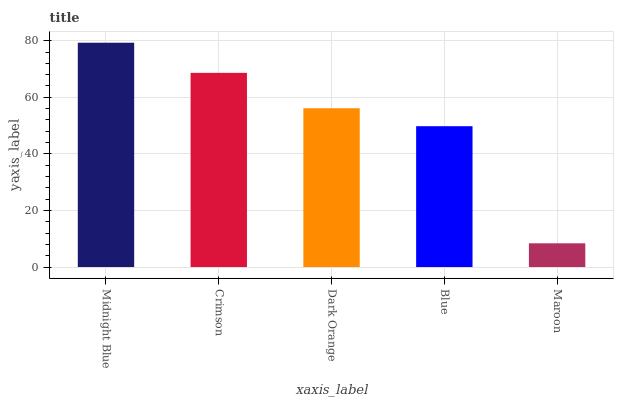Is Maroon the minimum?
Answer yes or no. Yes. Is Midnight Blue the maximum?
Answer yes or no. Yes. Is Crimson the minimum?
Answer yes or no. No. Is Crimson the maximum?
Answer yes or no. No. Is Midnight Blue greater than Crimson?
Answer yes or no. Yes. Is Crimson less than Midnight Blue?
Answer yes or no. Yes. Is Crimson greater than Midnight Blue?
Answer yes or no. No. Is Midnight Blue less than Crimson?
Answer yes or no. No. Is Dark Orange the high median?
Answer yes or no. Yes. Is Dark Orange the low median?
Answer yes or no. Yes. Is Crimson the high median?
Answer yes or no. No. Is Blue the low median?
Answer yes or no. No. 